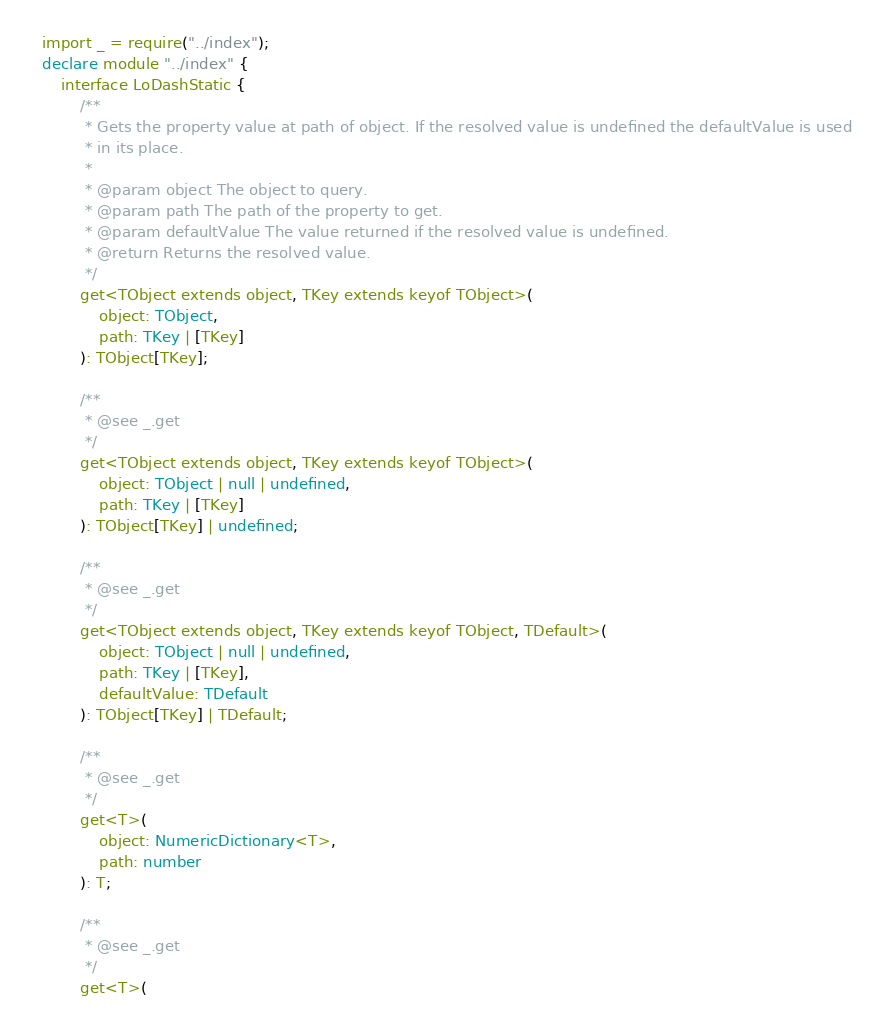<code> <loc_0><loc_0><loc_500><loc_500><_TypeScript_>import _ = require("../index");
declare module "../index" {
    interface LoDashStatic {
        /**
         * Gets the property value at path of object. If the resolved value is undefined the defaultValue is used
         * in its place.
         *
         * @param object The object to query.
         * @param path The path of the property to get.
         * @param defaultValue The value returned if the resolved value is undefined.
         * @return Returns the resolved value.
         */
        get<TObject extends object, TKey extends keyof TObject>(
            object: TObject,
            path: TKey | [TKey]
        ): TObject[TKey];

        /**
         * @see _.get
         */
        get<TObject extends object, TKey extends keyof TObject>(
            object: TObject | null | undefined,
            path: TKey | [TKey]
        ): TObject[TKey] | undefined;

        /**
         * @see _.get
         */
        get<TObject extends object, TKey extends keyof TObject, TDefault>(
            object: TObject | null | undefined,
            path: TKey | [TKey],
            defaultValue: TDefault
        ): TObject[TKey] | TDefault;

        /**
         * @see _.get
         */
        get<T>(
            object: NumericDictionary<T>,
            path: number
        ): T;

        /**
         * @see _.get
         */
        get<T>(</code> 